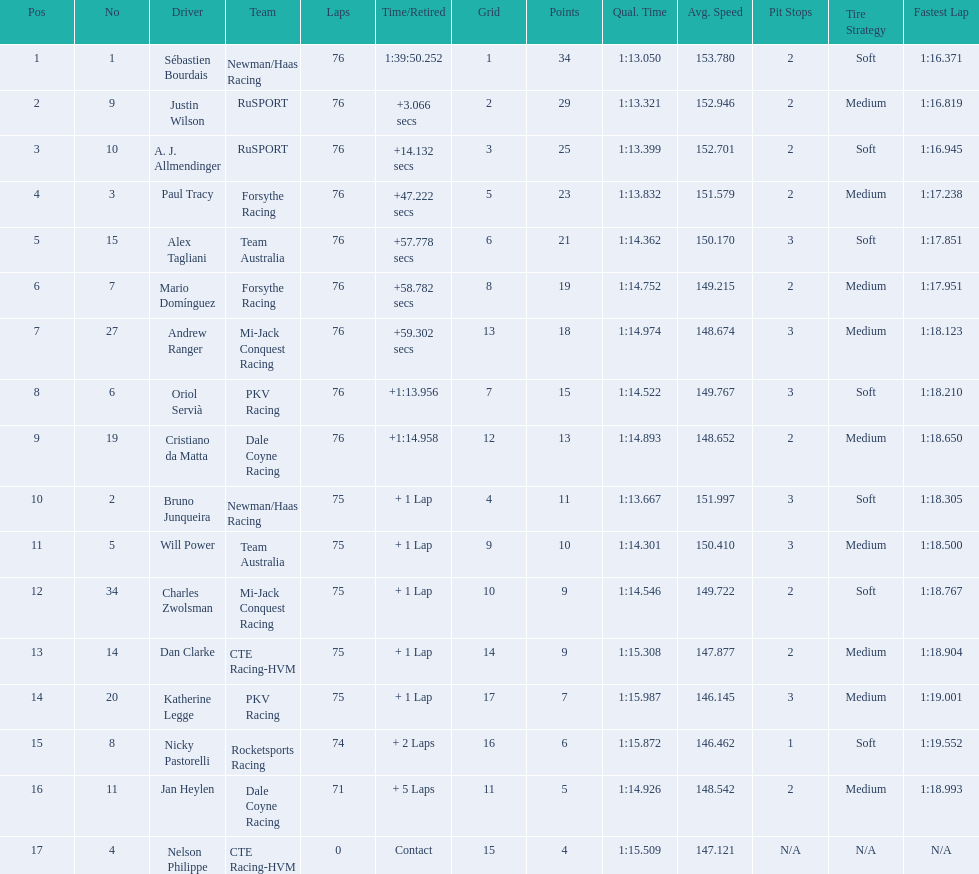Is there a driver named charles zwolsman? Charles Zwolsman. How many points did he acquire? 9. Were there any other entries that got the same number of points? 9. Who did that entry belong to? Dan Clarke. 